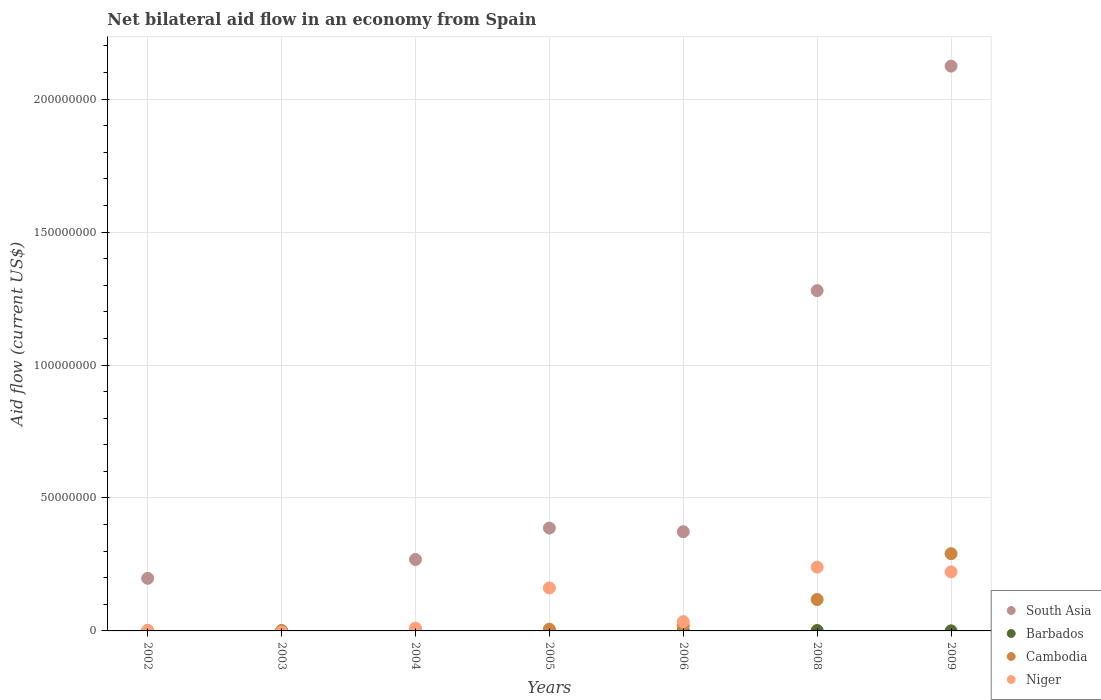How many different coloured dotlines are there?
Offer a very short reply. 4. Is the number of dotlines equal to the number of legend labels?
Your answer should be very brief. No. What is the net bilateral aid flow in Niger in 2006?
Give a very brief answer. 3.49e+06. Across all years, what is the maximum net bilateral aid flow in South Asia?
Your answer should be compact. 2.12e+08. Across all years, what is the minimum net bilateral aid flow in South Asia?
Your answer should be compact. 0. What is the difference between the net bilateral aid flow in Cambodia in 2002 and that in 2009?
Your answer should be very brief. -2.90e+07. What is the difference between the net bilateral aid flow in Barbados in 2006 and the net bilateral aid flow in Niger in 2002?
Ensure brevity in your answer.  -1.40e+05. What is the average net bilateral aid flow in Cambodia per year?
Ensure brevity in your answer.  6.25e+06. What is the ratio of the net bilateral aid flow in Cambodia in 2003 to that in 2006?
Provide a short and direct response. 0.06. Is the difference between the net bilateral aid flow in Barbados in 2002 and 2009 greater than the difference between the net bilateral aid flow in Cambodia in 2002 and 2009?
Provide a short and direct response. Yes. What is the difference between the highest and the second highest net bilateral aid flow in Barbados?
Provide a succinct answer. 1.30e+05. What is the difference between the highest and the lowest net bilateral aid flow in Cambodia?
Give a very brief answer. 2.90e+07. In how many years, is the net bilateral aid flow in Niger greater than the average net bilateral aid flow in Niger taken over all years?
Offer a terse response. 3. Does the net bilateral aid flow in South Asia monotonically increase over the years?
Offer a very short reply. No. Is the net bilateral aid flow in Barbados strictly greater than the net bilateral aid flow in Niger over the years?
Make the answer very short. No. Are the values on the major ticks of Y-axis written in scientific E-notation?
Provide a short and direct response. No. Does the graph contain any zero values?
Keep it short and to the point. Yes. Where does the legend appear in the graph?
Give a very brief answer. Bottom right. What is the title of the graph?
Keep it short and to the point. Net bilateral aid flow in an economy from Spain. Does "Tunisia" appear as one of the legend labels in the graph?
Your answer should be very brief. No. What is the label or title of the X-axis?
Keep it short and to the point. Years. What is the label or title of the Y-axis?
Make the answer very short. Aid flow (current US$). What is the Aid flow (current US$) of South Asia in 2002?
Provide a short and direct response. 1.98e+07. What is the Aid flow (current US$) of Barbados in 2002?
Ensure brevity in your answer.  2.00e+04. What is the Aid flow (current US$) in South Asia in 2003?
Offer a terse response. 0. What is the Aid flow (current US$) in Cambodia in 2003?
Offer a terse response. 1.20e+05. What is the Aid flow (current US$) of South Asia in 2004?
Offer a terse response. 2.69e+07. What is the Aid flow (current US$) of Barbados in 2004?
Keep it short and to the point. 2.00e+04. What is the Aid flow (current US$) of Niger in 2004?
Make the answer very short. 1.02e+06. What is the Aid flow (current US$) of South Asia in 2005?
Provide a succinct answer. 3.87e+07. What is the Aid flow (current US$) of Barbados in 2005?
Offer a terse response. 3.00e+04. What is the Aid flow (current US$) in Cambodia in 2005?
Offer a terse response. 6.50e+05. What is the Aid flow (current US$) in Niger in 2005?
Provide a short and direct response. 1.62e+07. What is the Aid flow (current US$) of South Asia in 2006?
Your response must be concise. 3.73e+07. What is the Aid flow (current US$) of Barbados in 2006?
Offer a terse response. 2.00e+04. What is the Aid flow (current US$) of Cambodia in 2006?
Keep it short and to the point. 1.97e+06. What is the Aid flow (current US$) of Niger in 2006?
Make the answer very short. 3.49e+06. What is the Aid flow (current US$) in South Asia in 2008?
Your response must be concise. 1.28e+08. What is the Aid flow (current US$) in Cambodia in 2008?
Keep it short and to the point. 1.18e+07. What is the Aid flow (current US$) of Niger in 2008?
Ensure brevity in your answer.  2.40e+07. What is the Aid flow (current US$) in South Asia in 2009?
Your answer should be very brief. 2.12e+08. What is the Aid flow (current US$) of Cambodia in 2009?
Ensure brevity in your answer.  2.90e+07. What is the Aid flow (current US$) in Niger in 2009?
Ensure brevity in your answer.  2.22e+07. Across all years, what is the maximum Aid flow (current US$) of South Asia?
Ensure brevity in your answer.  2.12e+08. Across all years, what is the maximum Aid flow (current US$) in Cambodia?
Offer a terse response. 2.90e+07. Across all years, what is the maximum Aid flow (current US$) of Niger?
Provide a succinct answer. 2.40e+07. Across all years, what is the minimum Aid flow (current US$) of South Asia?
Give a very brief answer. 0. Across all years, what is the minimum Aid flow (current US$) in Barbados?
Provide a short and direct response. 2.00e+04. Across all years, what is the minimum Aid flow (current US$) of Cambodia?
Your answer should be compact. 6.00e+04. What is the total Aid flow (current US$) of South Asia in the graph?
Provide a succinct answer. 4.63e+08. What is the total Aid flow (current US$) in Barbados in the graph?
Keep it short and to the point. 3.00e+05. What is the total Aid flow (current US$) in Cambodia in the graph?
Make the answer very short. 4.37e+07. What is the total Aid flow (current US$) in Niger in the graph?
Give a very brief answer. 6.70e+07. What is the difference between the Aid flow (current US$) of Barbados in 2002 and that in 2003?
Your answer should be very brief. 0. What is the difference between the Aid flow (current US$) of South Asia in 2002 and that in 2004?
Offer a very short reply. -7.07e+06. What is the difference between the Aid flow (current US$) in Niger in 2002 and that in 2004?
Offer a terse response. -8.60e+05. What is the difference between the Aid flow (current US$) in South Asia in 2002 and that in 2005?
Provide a succinct answer. -1.89e+07. What is the difference between the Aid flow (current US$) of Cambodia in 2002 and that in 2005?
Ensure brevity in your answer.  -5.80e+05. What is the difference between the Aid flow (current US$) of Niger in 2002 and that in 2005?
Keep it short and to the point. -1.60e+07. What is the difference between the Aid flow (current US$) in South Asia in 2002 and that in 2006?
Your response must be concise. -1.75e+07. What is the difference between the Aid flow (current US$) in Barbados in 2002 and that in 2006?
Offer a very short reply. 0. What is the difference between the Aid flow (current US$) of Cambodia in 2002 and that in 2006?
Offer a very short reply. -1.90e+06. What is the difference between the Aid flow (current US$) of Niger in 2002 and that in 2006?
Your response must be concise. -3.33e+06. What is the difference between the Aid flow (current US$) of South Asia in 2002 and that in 2008?
Ensure brevity in your answer.  -1.08e+08. What is the difference between the Aid flow (current US$) of Barbados in 2002 and that in 2008?
Your answer should be very brief. -1.40e+05. What is the difference between the Aid flow (current US$) in Cambodia in 2002 and that in 2008?
Provide a short and direct response. -1.17e+07. What is the difference between the Aid flow (current US$) in Niger in 2002 and that in 2008?
Your answer should be very brief. -2.38e+07. What is the difference between the Aid flow (current US$) of South Asia in 2002 and that in 2009?
Provide a succinct answer. -1.93e+08. What is the difference between the Aid flow (current US$) in Cambodia in 2002 and that in 2009?
Your answer should be compact. -2.90e+07. What is the difference between the Aid flow (current US$) in Niger in 2002 and that in 2009?
Offer a very short reply. -2.20e+07. What is the difference between the Aid flow (current US$) of Cambodia in 2003 and that in 2004?
Your answer should be very brief. 6.00e+04. What is the difference between the Aid flow (current US$) in Barbados in 2003 and that in 2005?
Offer a terse response. -10000. What is the difference between the Aid flow (current US$) of Cambodia in 2003 and that in 2005?
Ensure brevity in your answer.  -5.30e+05. What is the difference between the Aid flow (current US$) in Cambodia in 2003 and that in 2006?
Provide a succinct answer. -1.85e+06. What is the difference between the Aid flow (current US$) in Cambodia in 2003 and that in 2008?
Keep it short and to the point. -1.17e+07. What is the difference between the Aid flow (current US$) in Barbados in 2003 and that in 2009?
Make the answer very short. -10000. What is the difference between the Aid flow (current US$) in Cambodia in 2003 and that in 2009?
Ensure brevity in your answer.  -2.89e+07. What is the difference between the Aid flow (current US$) in South Asia in 2004 and that in 2005?
Give a very brief answer. -1.18e+07. What is the difference between the Aid flow (current US$) in Barbados in 2004 and that in 2005?
Offer a terse response. -10000. What is the difference between the Aid flow (current US$) of Cambodia in 2004 and that in 2005?
Offer a terse response. -5.90e+05. What is the difference between the Aid flow (current US$) of Niger in 2004 and that in 2005?
Give a very brief answer. -1.52e+07. What is the difference between the Aid flow (current US$) in South Asia in 2004 and that in 2006?
Give a very brief answer. -1.04e+07. What is the difference between the Aid flow (current US$) in Cambodia in 2004 and that in 2006?
Your answer should be compact. -1.91e+06. What is the difference between the Aid flow (current US$) of Niger in 2004 and that in 2006?
Your answer should be very brief. -2.47e+06. What is the difference between the Aid flow (current US$) in South Asia in 2004 and that in 2008?
Give a very brief answer. -1.01e+08. What is the difference between the Aid flow (current US$) in Cambodia in 2004 and that in 2008?
Ensure brevity in your answer.  -1.18e+07. What is the difference between the Aid flow (current US$) in Niger in 2004 and that in 2008?
Offer a terse response. -2.30e+07. What is the difference between the Aid flow (current US$) in South Asia in 2004 and that in 2009?
Provide a succinct answer. -1.86e+08. What is the difference between the Aid flow (current US$) in Cambodia in 2004 and that in 2009?
Offer a terse response. -2.90e+07. What is the difference between the Aid flow (current US$) of Niger in 2004 and that in 2009?
Your response must be concise. -2.12e+07. What is the difference between the Aid flow (current US$) of South Asia in 2005 and that in 2006?
Provide a short and direct response. 1.37e+06. What is the difference between the Aid flow (current US$) of Cambodia in 2005 and that in 2006?
Offer a terse response. -1.32e+06. What is the difference between the Aid flow (current US$) in Niger in 2005 and that in 2006?
Make the answer very short. 1.27e+07. What is the difference between the Aid flow (current US$) in South Asia in 2005 and that in 2008?
Your response must be concise. -8.93e+07. What is the difference between the Aid flow (current US$) in Cambodia in 2005 and that in 2008?
Your answer should be very brief. -1.12e+07. What is the difference between the Aid flow (current US$) of Niger in 2005 and that in 2008?
Your answer should be compact. -7.81e+06. What is the difference between the Aid flow (current US$) in South Asia in 2005 and that in 2009?
Provide a succinct answer. -1.74e+08. What is the difference between the Aid flow (current US$) in Barbados in 2005 and that in 2009?
Offer a very short reply. 0. What is the difference between the Aid flow (current US$) in Cambodia in 2005 and that in 2009?
Your answer should be very brief. -2.84e+07. What is the difference between the Aid flow (current US$) of Niger in 2005 and that in 2009?
Your answer should be very brief. -6.03e+06. What is the difference between the Aid flow (current US$) in South Asia in 2006 and that in 2008?
Provide a short and direct response. -9.07e+07. What is the difference between the Aid flow (current US$) in Barbados in 2006 and that in 2008?
Provide a short and direct response. -1.40e+05. What is the difference between the Aid flow (current US$) of Cambodia in 2006 and that in 2008?
Your response must be concise. -9.84e+06. What is the difference between the Aid flow (current US$) in Niger in 2006 and that in 2008?
Keep it short and to the point. -2.05e+07. What is the difference between the Aid flow (current US$) of South Asia in 2006 and that in 2009?
Provide a succinct answer. -1.75e+08. What is the difference between the Aid flow (current US$) of Barbados in 2006 and that in 2009?
Your answer should be compact. -10000. What is the difference between the Aid flow (current US$) in Cambodia in 2006 and that in 2009?
Provide a succinct answer. -2.71e+07. What is the difference between the Aid flow (current US$) in Niger in 2006 and that in 2009?
Give a very brief answer. -1.87e+07. What is the difference between the Aid flow (current US$) of South Asia in 2008 and that in 2009?
Offer a very short reply. -8.44e+07. What is the difference between the Aid flow (current US$) of Cambodia in 2008 and that in 2009?
Your response must be concise. -1.72e+07. What is the difference between the Aid flow (current US$) in Niger in 2008 and that in 2009?
Your response must be concise. 1.78e+06. What is the difference between the Aid flow (current US$) of South Asia in 2002 and the Aid flow (current US$) of Barbados in 2003?
Your answer should be compact. 1.98e+07. What is the difference between the Aid flow (current US$) in South Asia in 2002 and the Aid flow (current US$) in Cambodia in 2003?
Offer a terse response. 1.97e+07. What is the difference between the Aid flow (current US$) of South Asia in 2002 and the Aid flow (current US$) of Barbados in 2004?
Make the answer very short. 1.98e+07. What is the difference between the Aid flow (current US$) of South Asia in 2002 and the Aid flow (current US$) of Cambodia in 2004?
Offer a terse response. 1.97e+07. What is the difference between the Aid flow (current US$) in South Asia in 2002 and the Aid flow (current US$) in Niger in 2004?
Offer a terse response. 1.88e+07. What is the difference between the Aid flow (current US$) in Barbados in 2002 and the Aid flow (current US$) in Cambodia in 2004?
Provide a succinct answer. -4.00e+04. What is the difference between the Aid flow (current US$) in Barbados in 2002 and the Aid flow (current US$) in Niger in 2004?
Make the answer very short. -1.00e+06. What is the difference between the Aid flow (current US$) in Cambodia in 2002 and the Aid flow (current US$) in Niger in 2004?
Provide a short and direct response. -9.50e+05. What is the difference between the Aid flow (current US$) in South Asia in 2002 and the Aid flow (current US$) in Barbados in 2005?
Provide a short and direct response. 1.98e+07. What is the difference between the Aid flow (current US$) in South Asia in 2002 and the Aid flow (current US$) in Cambodia in 2005?
Your response must be concise. 1.91e+07. What is the difference between the Aid flow (current US$) in South Asia in 2002 and the Aid flow (current US$) in Niger in 2005?
Offer a very short reply. 3.62e+06. What is the difference between the Aid flow (current US$) in Barbados in 2002 and the Aid flow (current US$) in Cambodia in 2005?
Provide a short and direct response. -6.30e+05. What is the difference between the Aid flow (current US$) of Barbados in 2002 and the Aid flow (current US$) of Niger in 2005?
Provide a short and direct response. -1.62e+07. What is the difference between the Aid flow (current US$) of Cambodia in 2002 and the Aid flow (current US$) of Niger in 2005?
Offer a very short reply. -1.61e+07. What is the difference between the Aid flow (current US$) in South Asia in 2002 and the Aid flow (current US$) in Barbados in 2006?
Provide a short and direct response. 1.98e+07. What is the difference between the Aid flow (current US$) of South Asia in 2002 and the Aid flow (current US$) of Cambodia in 2006?
Provide a short and direct response. 1.78e+07. What is the difference between the Aid flow (current US$) in South Asia in 2002 and the Aid flow (current US$) in Niger in 2006?
Ensure brevity in your answer.  1.63e+07. What is the difference between the Aid flow (current US$) in Barbados in 2002 and the Aid flow (current US$) in Cambodia in 2006?
Offer a terse response. -1.95e+06. What is the difference between the Aid flow (current US$) of Barbados in 2002 and the Aid flow (current US$) of Niger in 2006?
Your response must be concise. -3.47e+06. What is the difference between the Aid flow (current US$) in Cambodia in 2002 and the Aid flow (current US$) in Niger in 2006?
Offer a very short reply. -3.42e+06. What is the difference between the Aid flow (current US$) of South Asia in 2002 and the Aid flow (current US$) of Barbados in 2008?
Provide a succinct answer. 1.96e+07. What is the difference between the Aid flow (current US$) of South Asia in 2002 and the Aid flow (current US$) of Cambodia in 2008?
Provide a short and direct response. 7.98e+06. What is the difference between the Aid flow (current US$) in South Asia in 2002 and the Aid flow (current US$) in Niger in 2008?
Provide a short and direct response. -4.19e+06. What is the difference between the Aid flow (current US$) of Barbados in 2002 and the Aid flow (current US$) of Cambodia in 2008?
Offer a very short reply. -1.18e+07. What is the difference between the Aid flow (current US$) in Barbados in 2002 and the Aid flow (current US$) in Niger in 2008?
Offer a terse response. -2.40e+07. What is the difference between the Aid flow (current US$) of Cambodia in 2002 and the Aid flow (current US$) of Niger in 2008?
Provide a succinct answer. -2.39e+07. What is the difference between the Aid flow (current US$) in South Asia in 2002 and the Aid flow (current US$) in Barbados in 2009?
Offer a very short reply. 1.98e+07. What is the difference between the Aid flow (current US$) of South Asia in 2002 and the Aid flow (current US$) of Cambodia in 2009?
Keep it short and to the point. -9.26e+06. What is the difference between the Aid flow (current US$) of South Asia in 2002 and the Aid flow (current US$) of Niger in 2009?
Provide a short and direct response. -2.41e+06. What is the difference between the Aid flow (current US$) in Barbados in 2002 and the Aid flow (current US$) in Cambodia in 2009?
Your response must be concise. -2.90e+07. What is the difference between the Aid flow (current US$) in Barbados in 2002 and the Aid flow (current US$) in Niger in 2009?
Your response must be concise. -2.22e+07. What is the difference between the Aid flow (current US$) of Cambodia in 2002 and the Aid flow (current US$) of Niger in 2009?
Make the answer very short. -2.21e+07. What is the difference between the Aid flow (current US$) of Barbados in 2003 and the Aid flow (current US$) of Cambodia in 2004?
Give a very brief answer. -4.00e+04. What is the difference between the Aid flow (current US$) of Cambodia in 2003 and the Aid flow (current US$) of Niger in 2004?
Your answer should be very brief. -9.00e+05. What is the difference between the Aid flow (current US$) in Barbados in 2003 and the Aid flow (current US$) in Cambodia in 2005?
Offer a very short reply. -6.30e+05. What is the difference between the Aid flow (current US$) in Barbados in 2003 and the Aid flow (current US$) in Niger in 2005?
Provide a short and direct response. -1.62e+07. What is the difference between the Aid flow (current US$) of Cambodia in 2003 and the Aid flow (current US$) of Niger in 2005?
Your answer should be compact. -1.60e+07. What is the difference between the Aid flow (current US$) in Barbados in 2003 and the Aid flow (current US$) in Cambodia in 2006?
Ensure brevity in your answer.  -1.95e+06. What is the difference between the Aid flow (current US$) in Barbados in 2003 and the Aid flow (current US$) in Niger in 2006?
Your response must be concise. -3.47e+06. What is the difference between the Aid flow (current US$) of Cambodia in 2003 and the Aid flow (current US$) of Niger in 2006?
Offer a very short reply. -3.37e+06. What is the difference between the Aid flow (current US$) of Barbados in 2003 and the Aid flow (current US$) of Cambodia in 2008?
Your response must be concise. -1.18e+07. What is the difference between the Aid flow (current US$) in Barbados in 2003 and the Aid flow (current US$) in Niger in 2008?
Offer a terse response. -2.40e+07. What is the difference between the Aid flow (current US$) in Cambodia in 2003 and the Aid flow (current US$) in Niger in 2008?
Offer a terse response. -2.39e+07. What is the difference between the Aid flow (current US$) of Barbados in 2003 and the Aid flow (current US$) of Cambodia in 2009?
Keep it short and to the point. -2.90e+07. What is the difference between the Aid flow (current US$) of Barbados in 2003 and the Aid flow (current US$) of Niger in 2009?
Your response must be concise. -2.22e+07. What is the difference between the Aid flow (current US$) of Cambodia in 2003 and the Aid flow (current US$) of Niger in 2009?
Provide a short and direct response. -2.21e+07. What is the difference between the Aid flow (current US$) of South Asia in 2004 and the Aid flow (current US$) of Barbados in 2005?
Give a very brief answer. 2.68e+07. What is the difference between the Aid flow (current US$) of South Asia in 2004 and the Aid flow (current US$) of Cambodia in 2005?
Your answer should be very brief. 2.62e+07. What is the difference between the Aid flow (current US$) of South Asia in 2004 and the Aid flow (current US$) of Niger in 2005?
Your response must be concise. 1.07e+07. What is the difference between the Aid flow (current US$) of Barbados in 2004 and the Aid flow (current US$) of Cambodia in 2005?
Offer a very short reply. -6.30e+05. What is the difference between the Aid flow (current US$) in Barbados in 2004 and the Aid flow (current US$) in Niger in 2005?
Make the answer very short. -1.62e+07. What is the difference between the Aid flow (current US$) in Cambodia in 2004 and the Aid flow (current US$) in Niger in 2005?
Offer a very short reply. -1.61e+07. What is the difference between the Aid flow (current US$) of South Asia in 2004 and the Aid flow (current US$) of Barbados in 2006?
Offer a very short reply. 2.68e+07. What is the difference between the Aid flow (current US$) of South Asia in 2004 and the Aid flow (current US$) of Cambodia in 2006?
Ensure brevity in your answer.  2.49e+07. What is the difference between the Aid flow (current US$) of South Asia in 2004 and the Aid flow (current US$) of Niger in 2006?
Your answer should be very brief. 2.34e+07. What is the difference between the Aid flow (current US$) in Barbados in 2004 and the Aid flow (current US$) in Cambodia in 2006?
Your answer should be very brief. -1.95e+06. What is the difference between the Aid flow (current US$) of Barbados in 2004 and the Aid flow (current US$) of Niger in 2006?
Your response must be concise. -3.47e+06. What is the difference between the Aid flow (current US$) of Cambodia in 2004 and the Aid flow (current US$) of Niger in 2006?
Offer a very short reply. -3.43e+06. What is the difference between the Aid flow (current US$) in South Asia in 2004 and the Aid flow (current US$) in Barbados in 2008?
Ensure brevity in your answer.  2.67e+07. What is the difference between the Aid flow (current US$) of South Asia in 2004 and the Aid flow (current US$) of Cambodia in 2008?
Offer a very short reply. 1.50e+07. What is the difference between the Aid flow (current US$) in South Asia in 2004 and the Aid flow (current US$) in Niger in 2008?
Keep it short and to the point. 2.88e+06. What is the difference between the Aid flow (current US$) in Barbados in 2004 and the Aid flow (current US$) in Cambodia in 2008?
Offer a terse response. -1.18e+07. What is the difference between the Aid flow (current US$) of Barbados in 2004 and the Aid flow (current US$) of Niger in 2008?
Provide a succinct answer. -2.40e+07. What is the difference between the Aid flow (current US$) in Cambodia in 2004 and the Aid flow (current US$) in Niger in 2008?
Offer a terse response. -2.39e+07. What is the difference between the Aid flow (current US$) in South Asia in 2004 and the Aid flow (current US$) in Barbados in 2009?
Provide a short and direct response. 2.68e+07. What is the difference between the Aid flow (current US$) in South Asia in 2004 and the Aid flow (current US$) in Cambodia in 2009?
Offer a terse response. -2.19e+06. What is the difference between the Aid flow (current US$) of South Asia in 2004 and the Aid flow (current US$) of Niger in 2009?
Make the answer very short. 4.66e+06. What is the difference between the Aid flow (current US$) in Barbados in 2004 and the Aid flow (current US$) in Cambodia in 2009?
Your answer should be compact. -2.90e+07. What is the difference between the Aid flow (current US$) of Barbados in 2004 and the Aid flow (current US$) of Niger in 2009?
Give a very brief answer. -2.22e+07. What is the difference between the Aid flow (current US$) in Cambodia in 2004 and the Aid flow (current US$) in Niger in 2009?
Provide a short and direct response. -2.21e+07. What is the difference between the Aid flow (current US$) in South Asia in 2005 and the Aid flow (current US$) in Barbados in 2006?
Ensure brevity in your answer.  3.87e+07. What is the difference between the Aid flow (current US$) in South Asia in 2005 and the Aid flow (current US$) in Cambodia in 2006?
Your response must be concise. 3.67e+07. What is the difference between the Aid flow (current US$) of South Asia in 2005 and the Aid flow (current US$) of Niger in 2006?
Give a very brief answer. 3.52e+07. What is the difference between the Aid flow (current US$) of Barbados in 2005 and the Aid flow (current US$) of Cambodia in 2006?
Keep it short and to the point. -1.94e+06. What is the difference between the Aid flow (current US$) of Barbados in 2005 and the Aid flow (current US$) of Niger in 2006?
Provide a short and direct response. -3.46e+06. What is the difference between the Aid flow (current US$) in Cambodia in 2005 and the Aid flow (current US$) in Niger in 2006?
Give a very brief answer. -2.84e+06. What is the difference between the Aid flow (current US$) in South Asia in 2005 and the Aid flow (current US$) in Barbados in 2008?
Provide a succinct answer. 3.85e+07. What is the difference between the Aid flow (current US$) of South Asia in 2005 and the Aid flow (current US$) of Cambodia in 2008?
Make the answer very short. 2.69e+07. What is the difference between the Aid flow (current US$) in South Asia in 2005 and the Aid flow (current US$) in Niger in 2008?
Provide a short and direct response. 1.47e+07. What is the difference between the Aid flow (current US$) of Barbados in 2005 and the Aid flow (current US$) of Cambodia in 2008?
Your response must be concise. -1.18e+07. What is the difference between the Aid flow (current US$) of Barbados in 2005 and the Aid flow (current US$) of Niger in 2008?
Provide a short and direct response. -2.40e+07. What is the difference between the Aid flow (current US$) in Cambodia in 2005 and the Aid flow (current US$) in Niger in 2008?
Your answer should be very brief. -2.33e+07. What is the difference between the Aid flow (current US$) in South Asia in 2005 and the Aid flow (current US$) in Barbados in 2009?
Your answer should be compact. 3.86e+07. What is the difference between the Aid flow (current US$) of South Asia in 2005 and the Aid flow (current US$) of Cambodia in 2009?
Make the answer very short. 9.63e+06. What is the difference between the Aid flow (current US$) in South Asia in 2005 and the Aid flow (current US$) in Niger in 2009?
Make the answer very short. 1.65e+07. What is the difference between the Aid flow (current US$) in Barbados in 2005 and the Aid flow (current US$) in Cambodia in 2009?
Make the answer very short. -2.90e+07. What is the difference between the Aid flow (current US$) of Barbados in 2005 and the Aid flow (current US$) of Niger in 2009?
Your response must be concise. -2.22e+07. What is the difference between the Aid flow (current US$) of Cambodia in 2005 and the Aid flow (current US$) of Niger in 2009?
Make the answer very short. -2.16e+07. What is the difference between the Aid flow (current US$) of South Asia in 2006 and the Aid flow (current US$) of Barbados in 2008?
Provide a short and direct response. 3.72e+07. What is the difference between the Aid flow (current US$) in South Asia in 2006 and the Aid flow (current US$) in Cambodia in 2008?
Your answer should be compact. 2.55e+07. What is the difference between the Aid flow (current US$) of South Asia in 2006 and the Aid flow (current US$) of Niger in 2008?
Give a very brief answer. 1.33e+07. What is the difference between the Aid flow (current US$) of Barbados in 2006 and the Aid flow (current US$) of Cambodia in 2008?
Make the answer very short. -1.18e+07. What is the difference between the Aid flow (current US$) of Barbados in 2006 and the Aid flow (current US$) of Niger in 2008?
Offer a very short reply. -2.40e+07. What is the difference between the Aid flow (current US$) in Cambodia in 2006 and the Aid flow (current US$) in Niger in 2008?
Your answer should be very brief. -2.20e+07. What is the difference between the Aid flow (current US$) in South Asia in 2006 and the Aid flow (current US$) in Barbados in 2009?
Your response must be concise. 3.73e+07. What is the difference between the Aid flow (current US$) in South Asia in 2006 and the Aid flow (current US$) in Cambodia in 2009?
Give a very brief answer. 8.26e+06. What is the difference between the Aid flow (current US$) of South Asia in 2006 and the Aid flow (current US$) of Niger in 2009?
Provide a succinct answer. 1.51e+07. What is the difference between the Aid flow (current US$) of Barbados in 2006 and the Aid flow (current US$) of Cambodia in 2009?
Your answer should be compact. -2.90e+07. What is the difference between the Aid flow (current US$) of Barbados in 2006 and the Aid flow (current US$) of Niger in 2009?
Offer a terse response. -2.22e+07. What is the difference between the Aid flow (current US$) of Cambodia in 2006 and the Aid flow (current US$) of Niger in 2009?
Your answer should be very brief. -2.02e+07. What is the difference between the Aid flow (current US$) in South Asia in 2008 and the Aid flow (current US$) in Barbados in 2009?
Your answer should be very brief. 1.28e+08. What is the difference between the Aid flow (current US$) in South Asia in 2008 and the Aid flow (current US$) in Cambodia in 2009?
Your answer should be very brief. 9.89e+07. What is the difference between the Aid flow (current US$) of South Asia in 2008 and the Aid flow (current US$) of Niger in 2009?
Offer a terse response. 1.06e+08. What is the difference between the Aid flow (current US$) in Barbados in 2008 and the Aid flow (current US$) in Cambodia in 2009?
Your answer should be very brief. -2.89e+07. What is the difference between the Aid flow (current US$) in Barbados in 2008 and the Aid flow (current US$) in Niger in 2009?
Ensure brevity in your answer.  -2.20e+07. What is the difference between the Aid flow (current US$) of Cambodia in 2008 and the Aid flow (current US$) of Niger in 2009?
Keep it short and to the point. -1.04e+07. What is the average Aid flow (current US$) in South Asia per year?
Offer a terse response. 6.61e+07. What is the average Aid flow (current US$) of Barbados per year?
Ensure brevity in your answer.  4.29e+04. What is the average Aid flow (current US$) of Cambodia per year?
Provide a short and direct response. 6.25e+06. What is the average Aid flow (current US$) of Niger per year?
Your response must be concise. 9.57e+06. In the year 2002, what is the difference between the Aid flow (current US$) of South Asia and Aid flow (current US$) of Barbados?
Provide a short and direct response. 1.98e+07. In the year 2002, what is the difference between the Aid flow (current US$) in South Asia and Aid flow (current US$) in Cambodia?
Offer a terse response. 1.97e+07. In the year 2002, what is the difference between the Aid flow (current US$) of South Asia and Aid flow (current US$) of Niger?
Your answer should be very brief. 1.96e+07. In the year 2002, what is the difference between the Aid flow (current US$) of Barbados and Aid flow (current US$) of Niger?
Your answer should be compact. -1.40e+05. In the year 2004, what is the difference between the Aid flow (current US$) of South Asia and Aid flow (current US$) of Barbados?
Your answer should be compact. 2.68e+07. In the year 2004, what is the difference between the Aid flow (current US$) of South Asia and Aid flow (current US$) of Cambodia?
Provide a short and direct response. 2.68e+07. In the year 2004, what is the difference between the Aid flow (current US$) of South Asia and Aid flow (current US$) of Niger?
Your response must be concise. 2.58e+07. In the year 2004, what is the difference between the Aid flow (current US$) of Cambodia and Aid flow (current US$) of Niger?
Offer a very short reply. -9.60e+05. In the year 2005, what is the difference between the Aid flow (current US$) of South Asia and Aid flow (current US$) of Barbados?
Your answer should be compact. 3.86e+07. In the year 2005, what is the difference between the Aid flow (current US$) in South Asia and Aid flow (current US$) in Cambodia?
Provide a succinct answer. 3.80e+07. In the year 2005, what is the difference between the Aid flow (current US$) of South Asia and Aid flow (current US$) of Niger?
Make the answer very short. 2.25e+07. In the year 2005, what is the difference between the Aid flow (current US$) in Barbados and Aid flow (current US$) in Cambodia?
Your answer should be compact. -6.20e+05. In the year 2005, what is the difference between the Aid flow (current US$) of Barbados and Aid flow (current US$) of Niger?
Keep it short and to the point. -1.61e+07. In the year 2005, what is the difference between the Aid flow (current US$) in Cambodia and Aid flow (current US$) in Niger?
Ensure brevity in your answer.  -1.55e+07. In the year 2006, what is the difference between the Aid flow (current US$) in South Asia and Aid flow (current US$) in Barbados?
Give a very brief answer. 3.73e+07. In the year 2006, what is the difference between the Aid flow (current US$) in South Asia and Aid flow (current US$) in Cambodia?
Your response must be concise. 3.53e+07. In the year 2006, what is the difference between the Aid flow (current US$) of South Asia and Aid flow (current US$) of Niger?
Keep it short and to the point. 3.38e+07. In the year 2006, what is the difference between the Aid flow (current US$) in Barbados and Aid flow (current US$) in Cambodia?
Ensure brevity in your answer.  -1.95e+06. In the year 2006, what is the difference between the Aid flow (current US$) of Barbados and Aid flow (current US$) of Niger?
Make the answer very short. -3.47e+06. In the year 2006, what is the difference between the Aid flow (current US$) of Cambodia and Aid flow (current US$) of Niger?
Offer a terse response. -1.52e+06. In the year 2008, what is the difference between the Aid flow (current US$) in South Asia and Aid flow (current US$) in Barbados?
Your answer should be very brief. 1.28e+08. In the year 2008, what is the difference between the Aid flow (current US$) of South Asia and Aid flow (current US$) of Cambodia?
Give a very brief answer. 1.16e+08. In the year 2008, what is the difference between the Aid flow (current US$) of South Asia and Aid flow (current US$) of Niger?
Your response must be concise. 1.04e+08. In the year 2008, what is the difference between the Aid flow (current US$) in Barbados and Aid flow (current US$) in Cambodia?
Make the answer very short. -1.16e+07. In the year 2008, what is the difference between the Aid flow (current US$) of Barbados and Aid flow (current US$) of Niger?
Ensure brevity in your answer.  -2.38e+07. In the year 2008, what is the difference between the Aid flow (current US$) in Cambodia and Aid flow (current US$) in Niger?
Keep it short and to the point. -1.22e+07. In the year 2009, what is the difference between the Aid flow (current US$) in South Asia and Aid flow (current US$) in Barbados?
Provide a succinct answer. 2.12e+08. In the year 2009, what is the difference between the Aid flow (current US$) in South Asia and Aid flow (current US$) in Cambodia?
Keep it short and to the point. 1.83e+08. In the year 2009, what is the difference between the Aid flow (current US$) of South Asia and Aid flow (current US$) of Niger?
Your answer should be very brief. 1.90e+08. In the year 2009, what is the difference between the Aid flow (current US$) of Barbados and Aid flow (current US$) of Cambodia?
Keep it short and to the point. -2.90e+07. In the year 2009, what is the difference between the Aid flow (current US$) of Barbados and Aid flow (current US$) of Niger?
Your answer should be very brief. -2.22e+07. In the year 2009, what is the difference between the Aid flow (current US$) in Cambodia and Aid flow (current US$) in Niger?
Ensure brevity in your answer.  6.85e+06. What is the ratio of the Aid flow (current US$) in Barbados in 2002 to that in 2003?
Offer a terse response. 1. What is the ratio of the Aid flow (current US$) in Cambodia in 2002 to that in 2003?
Your response must be concise. 0.58. What is the ratio of the Aid flow (current US$) in South Asia in 2002 to that in 2004?
Give a very brief answer. 0.74. What is the ratio of the Aid flow (current US$) of Cambodia in 2002 to that in 2004?
Make the answer very short. 1.17. What is the ratio of the Aid flow (current US$) of Niger in 2002 to that in 2004?
Provide a short and direct response. 0.16. What is the ratio of the Aid flow (current US$) of South Asia in 2002 to that in 2005?
Offer a very short reply. 0.51. What is the ratio of the Aid flow (current US$) in Cambodia in 2002 to that in 2005?
Keep it short and to the point. 0.11. What is the ratio of the Aid flow (current US$) of Niger in 2002 to that in 2005?
Your response must be concise. 0.01. What is the ratio of the Aid flow (current US$) of South Asia in 2002 to that in 2006?
Provide a short and direct response. 0.53. What is the ratio of the Aid flow (current US$) in Barbados in 2002 to that in 2006?
Provide a succinct answer. 1. What is the ratio of the Aid flow (current US$) of Cambodia in 2002 to that in 2006?
Provide a short and direct response. 0.04. What is the ratio of the Aid flow (current US$) of Niger in 2002 to that in 2006?
Keep it short and to the point. 0.05. What is the ratio of the Aid flow (current US$) of South Asia in 2002 to that in 2008?
Your answer should be very brief. 0.15. What is the ratio of the Aid flow (current US$) in Barbados in 2002 to that in 2008?
Provide a short and direct response. 0.12. What is the ratio of the Aid flow (current US$) of Cambodia in 2002 to that in 2008?
Your response must be concise. 0.01. What is the ratio of the Aid flow (current US$) of Niger in 2002 to that in 2008?
Keep it short and to the point. 0.01. What is the ratio of the Aid flow (current US$) of South Asia in 2002 to that in 2009?
Offer a very short reply. 0.09. What is the ratio of the Aid flow (current US$) of Barbados in 2002 to that in 2009?
Your response must be concise. 0.67. What is the ratio of the Aid flow (current US$) in Cambodia in 2002 to that in 2009?
Your answer should be very brief. 0. What is the ratio of the Aid flow (current US$) in Niger in 2002 to that in 2009?
Your answer should be very brief. 0.01. What is the ratio of the Aid flow (current US$) in Barbados in 2003 to that in 2004?
Provide a short and direct response. 1. What is the ratio of the Aid flow (current US$) in Cambodia in 2003 to that in 2005?
Your answer should be very brief. 0.18. What is the ratio of the Aid flow (current US$) in Barbados in 2003 to that in 2006?
Offer a terse response. 1. What is the ratio of the Aid flow (current US$) of Cambodia in 2003 to that in 2006?
Provide a succinct answer. 0.06. What is the ratio of the Aid flow (current US$) in Cambodia in 2003 to that in 2008?
Your answer should be compact. 0.01. What is the ratio of the Aid flow (current US$) in Barbados in 2003 to that in 2009?
Offer a very short reply. 0.67. What is the ratio of the Aid flow (current US$) of Cambodia in 2003 to that in 2009?
Provide a short and direct response. 0. What is the ratio of the Aid flow (current US$) in South Asia in 2004 to that in 2005?
Ensure brevity in your answer.  0.69. What is the ratio of the Aid flow (current US$) in Barbados in 2004 to that in 2005?
Ensure brevity in your answer.  0.67. What is the ratio of the Aid flow (current US$) in Cambodia in 2004 to that in 2005?
Your answer should be compact. 0.09. What is the ratio of the Aid flow (current US$) in Niger in 2004 to that in 2005?
Give a very brief answer. 0.06. What is the ratio of the Aid flow (current US$) of South Asia in 2004 to that in 2006?
Provide a short and direct response. 0.72. What is the ratio of the Aid flow (current US$) in Barbados in 2004 to that in 2006?
Offer a very short reply. 1. What is the ratio of the Aid flow (current US$) of Cambodia in 2004 to that in 2006?
Provide a succinct answer. 0.03. What is the ratio of the Aid flow (current US$) of Niger in 2004 to that in 2006?
Your response must be concise. 0.29. What is the ratio of the Aid flow (current US$) in South Asia in 2004 to that in 2008?
Keep it short and to the point. 0.21. What is the ratio of the Aid flow (current US$) of Barbados in 2004 to that in 2008?
Your answer should be very brief. 0.12. What is the ratio of the Aid flow (current US$) of Cambodia in 2004 to that in 2008?
Your answer should be compact. 0.01. What is the ratio of the Aid flow (current US$) of Niger in 2004 to that in 2008?
Keep it short and to the point. 0.04. What is the ratio of the Aid flow (current US$) of South Asia in 2004 to that in 2009?
Ensure brevity in your answer.  0.13. What is the ratio of the Aid flow (current US$) of Cambodia in 2004 to that in 2009?
Offer a terse response. 0. What is the ratio of the Aid flow (current US$) in Niger in 2004 to that in 2009?
Offer a terse response. 0.05. What is the ratio of the Aid flow (current US$) of South Asia in 2005 to that in 2006?
Keep it short and to the point. 1.04. What is the ratio of the Aid flow (current US$) in Cambodia in 2005 to that in 2006?
Give a very brief answer. 0.33. What is the ratio of the Aid flow (current US$) of Niger in 2005 to that in 2006?
Make the answer very short. 4.63. What is the ratio of the Aid flow (current US$) of South Asia in 2005 to that in 2008?
Keep it short and to the point. 0.3. What is the ratio of the Aid flow (current US$) in Barbados in 2005 to that in 2008?
Offer a terse response. 0.19. What is the ratio of the Aid flow (current US$) of Cambodia in 2005 to that in 2008?
Ensure brevity in your answer.  0.06. What is the ratio of the Aid flow (current US$) of Niger in 2005 to that in 2008?
Ensure brevity in your answer.  0.67. What is the ratio of the Aid flow (current US$) in South Asia in 2005 to that in 2009?
Offer a very short reply. 0.18. What is the ratio of the Aid flow (current US$) of Cambodia in 2005 to that in 2009?
Provide a succinct answer. 0.02. What is the ratio of the Aid flow (current US$) in Niger in 2005 to that in 2009?
Your answer should be compact. 0.73. What is the ratio of the Aid flow (current US$) in South Asia in 2006 to that in 2008?
Provide a succinct answer. 0.29. What is the ratio of the Aid flow (current US$) of Barbados in 2006 to that in 2008?
Offer a terse response. 0.12. What is the ratio of the Aid flow (current US$) in Cambodia in 2006 to that in 2008?
Keep it short and to the point. 0.17. What is the ratio of the Aid flow (current US$) in Niger in 2006 to that in 2008?
Ensure brevity in your answer.  0.15. What is the ratio of the Aid flow (current US$) in South Asia in 2006 to that in 2009?
Offer a terse response. 0.18. What is the ratio of the Aid flow (current US$) of Cambodia in 2006 to that in 2009?
Make the answer very short. 0.07. What is the ratio of the Aid flow (current US$) in Niger in 2006 to that in 2009?
Offer a terse response. 0.16. What is the ratio of the Aid flow (current US$) of South Asia in 2008 to that in 2009?
Your answer should be very brief. 0.6. What is the ratio of the Aid flow (current US$) of Barbados in 2008 to that in 2009?
Provide a succinct answer. 5.33. What is the ratio of the Aid flow (current US$) in Cambodia in 2008 to that in 2009?
Ensure brevity in your answer.  0.41. What is the ratio of the Aid flow (current US$) in Niger in 2008 to that in 2009?
Your answer should be very brief. 1.08. What is the difference between the highest and the second highest Aid flow (current US$) of South Asia?
Your answer should be very brief. 8.44e+07. What is the difference between the highest and the second highest Aid flow (current US$) in Barbados?
Ensure brevity in your answer.  1.30e+05. What is the difference between the highest and the second highest Aid flow (current US$) of Cambodia?
Your answer should be compact. 1.72e+07. What is the difference between the highest and the second highest Aid flow (current US$) of Niger?
Your answer should be very brief. 1.78e+06. What is the difference between the highest and the lowest Aid flow (current US$) of South Asia?
Give a very brief answer. 2.12e+08. What is the difference between the highest and the lowest Aid flow (current US$) of Cambodia?
Your response must be concise. 2.90e+07. What is the difference between the highest and the lowest Aid flow (current US$) of Niger?
Offer a very short reply. 2.40e+07. 